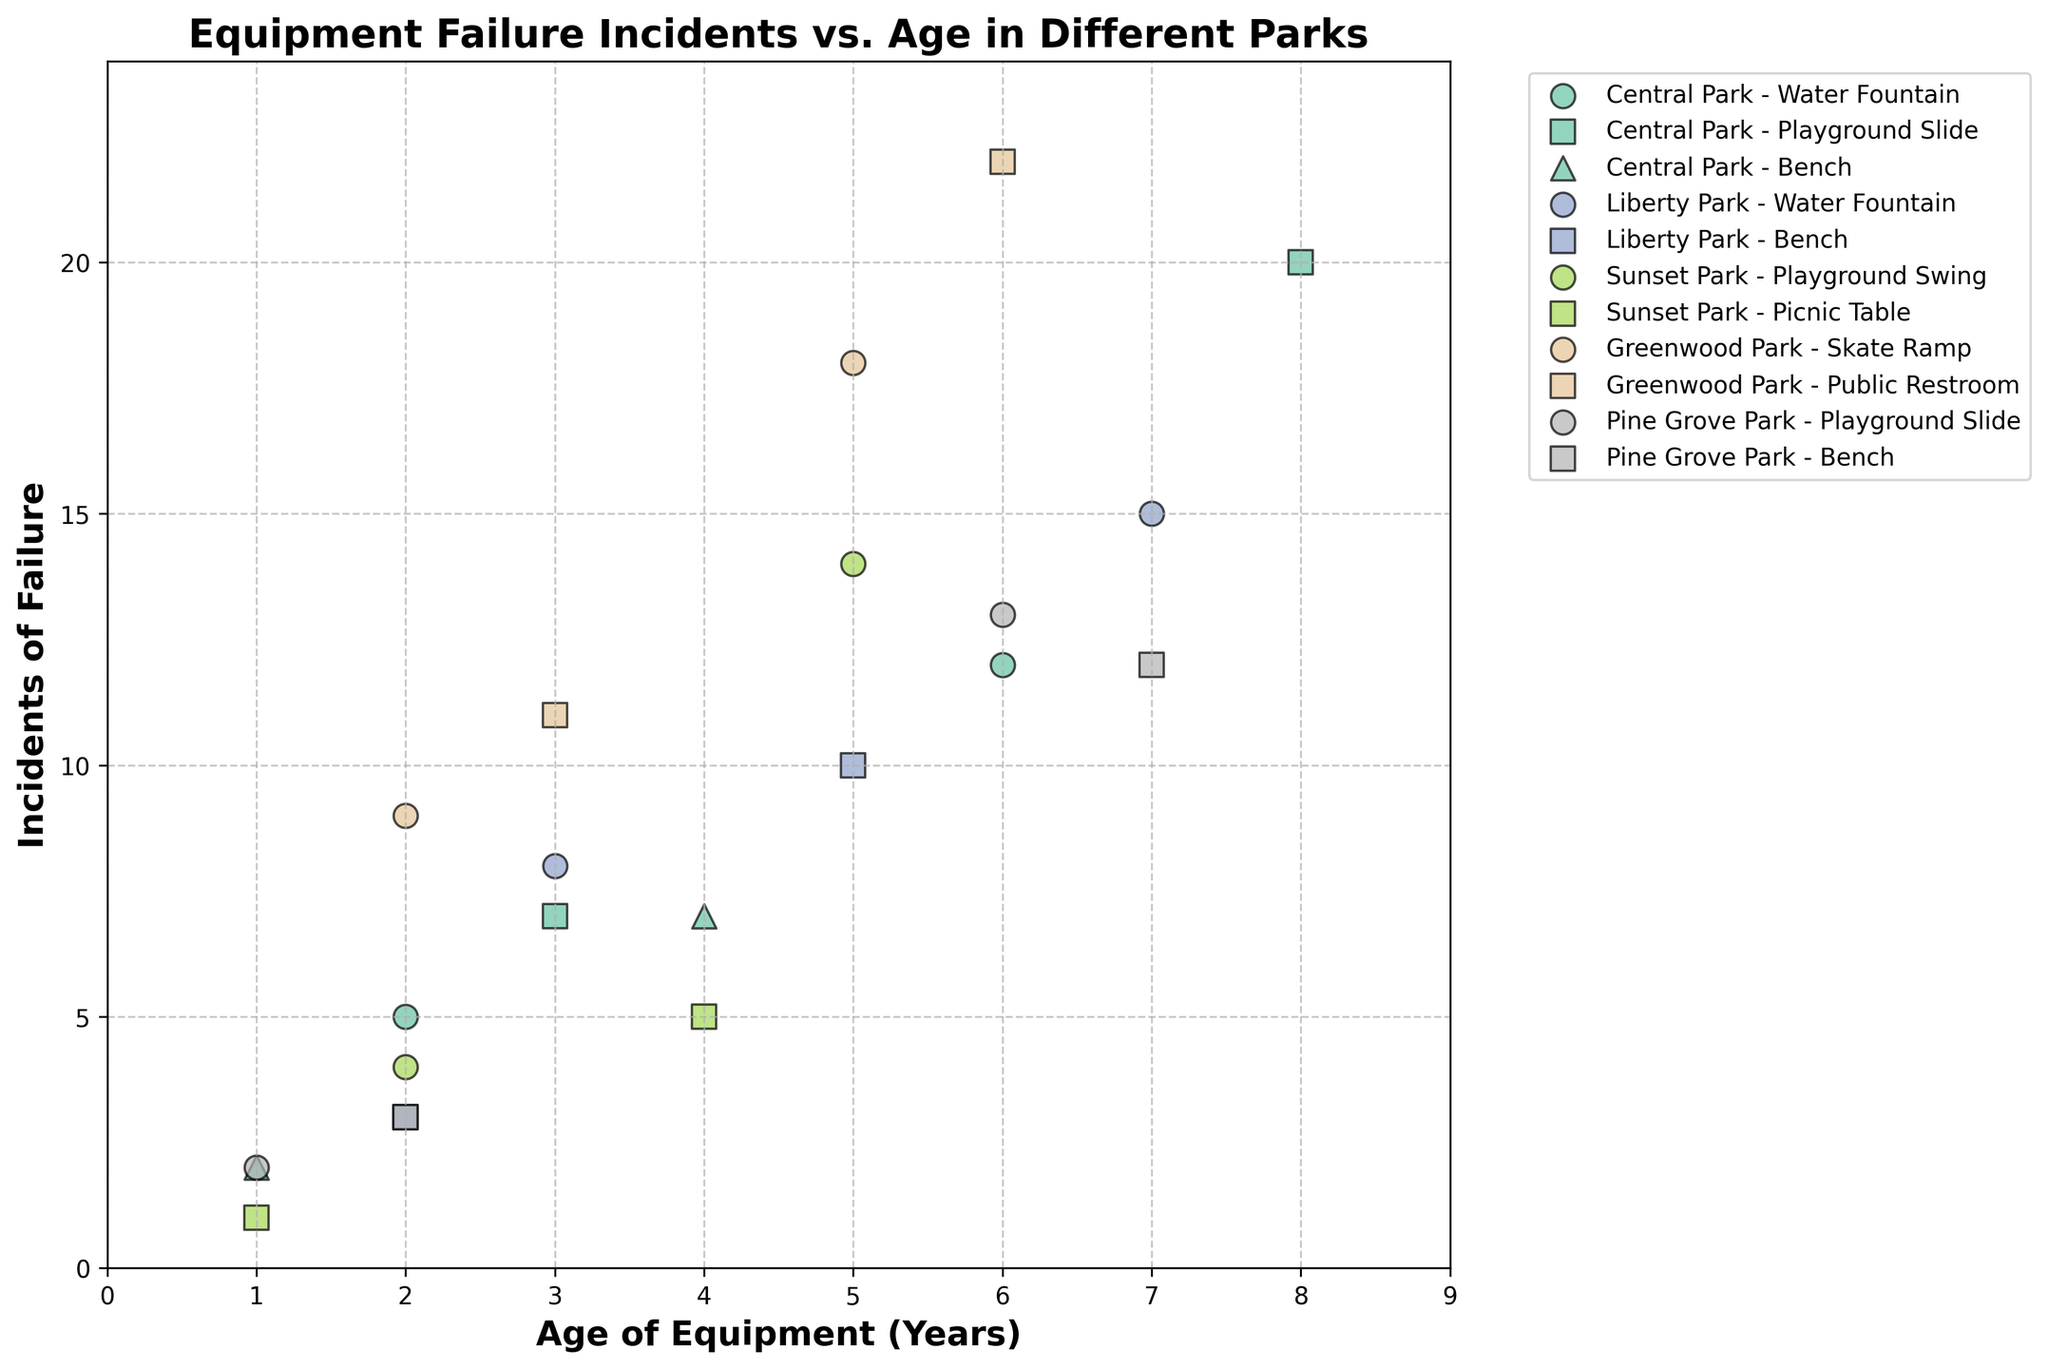How does the incidence of failure of the Playground Slide in Central Park at age 3 compare to age 8? Looking at the scatter plot, find the markers representing Central Park's Playground Slide at age 3 and age 8. Check the y-axis values for incidents of failure. Age 3 has 7 incidents and age 8 has 20 incidents. Therefore, the incidence of failure increases as the equipment ages.
Answer: Incidents increased from 7 to 20 What is the title of the scatter plot? The title of the scatter plot is usually displayed at the top of the figure. Here, it states the main focus of the graph.
Answer: Equipment Failure Incidents vs. Age in Different Parks Which park has the highest number of equipment failure incidents at any age? Identify the park with the highest single data point by checking the maximum y-value. Here, Greenwood Park's Public Restroom data point at age 6 achieves the highest value on the y-axis with 22 incidents.
Answer: Greenwood Park How many types of equipment are displayed for Central Park? In the figure, each equipment type is assigned a unique marker. For Central Park, count the different markers for each equipment type listed in the legend associated with the park.
Answer: 3 types What is the average number of incidents of failure for the Water Fountain equipment in both Central Park and Liberty Park? First, find the y-values for all Water Fountain data points in Central Park (5, 12) and Liberty Park (8, 15). Sum these values and divide by the number of points (4): (5+12+8+15)/4.
Answer: 10 At what age does the Bench equipment in Liberty Park experience its first recorded failure? Inspect the x-values for the Bench markers in Liberty Park. The smallest x-value indicates the age at which the first failure occurs.
Answer: Age 2 Which equipment type in Sunset Park shows the least number of incidents of failure at age 4? Find the equipment types in Sunset Park that appear at age 4 on the x-axis and compare their y-values. The Picnic Table has 5 incidents, which is the least among available types.
Answer: Picnic Table Compare the trends of incidents of failure with age between the Skate Ramp in Greenwood Park and the Playground Slide in Pine Grove Park. Observe how the number of incidents change with age for both equipment types by following the slope and positions of their markers. Skate Ramp incidents increase more steeply than Playground Slide over the similar age range.
Answer: Skate Ramp increases more steeply What are the maximum age and maximum incidents of failure recorded in the plot? The x-axis denotes age, and the y-axis denotes incidents of failure. Find the highest values along both axes.
Answer: Age 7, Incidents 22 Which park has the lowest incidents of failure for the Playground Swing at age 5? Find the Playground Swing marker for age 5 in all relevant parks and compare their y-values. Sunset Park is the only entry for Playground Swing at age 5 with 14 incidents.
Answer: Sunset Park 